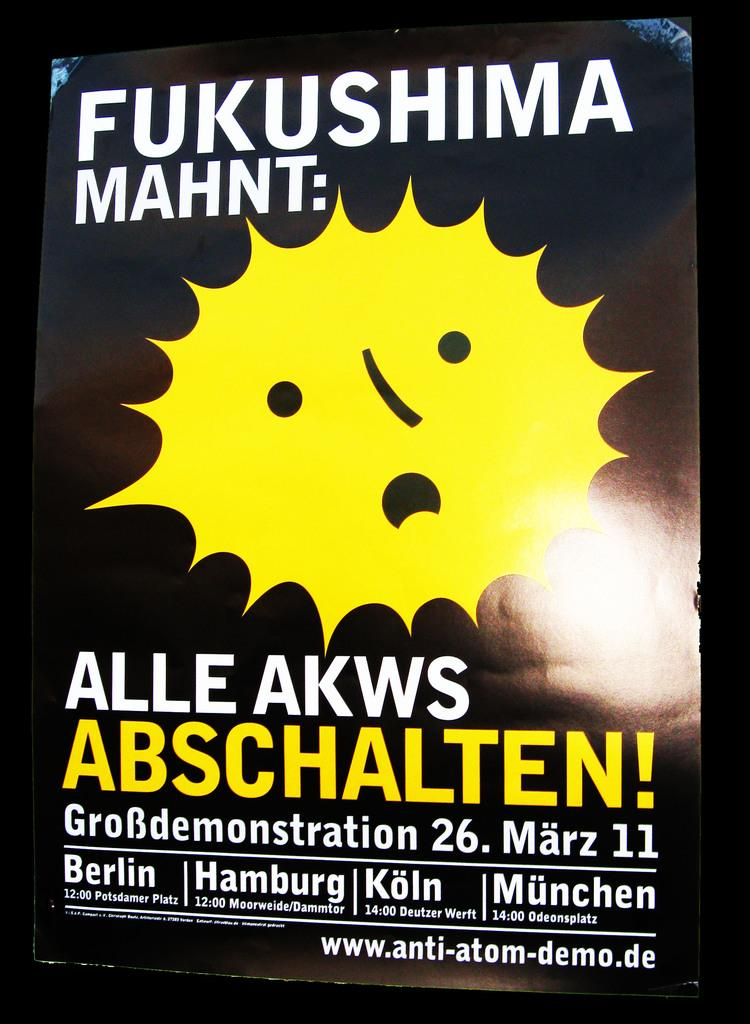What type of visual is depicted in the image? The image is a poster. What can be found on the poster besides the background? There is text on the poster. How would you describe the color of the background in the poster? The background of the poster is dark. What type of celery is being used as a note in the image? There is no celery or note present in the image. What verse can be found on the poster in the image? There is no verse mentioned in the provided facts about the image. 